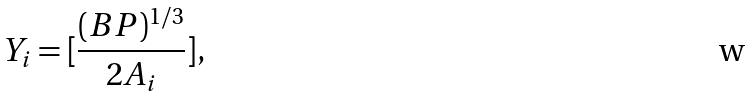Convert formula to latex. <formula><loc_0><loc_0><loc_500><loc_500>Y _ { i } = [ \frac { ( B P ) ^ { 1 / 3 } } { 2 A _ { i } } ] ,</formula> 